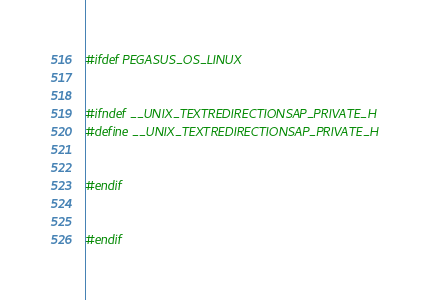Convert code to text. <code><loc_0><loc_0><loc_500><loc_500><_C++_>#ifdef PEGASUS_OS_LINUX


#ifndef __UNIX_TEXTREDIRECTIONSAP_PRIVATE_H
#define __UNIX_TEXTREDIRECTIONSAP_PRIVATE_H


#endif


#endif
</code> 